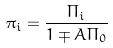<formula> <loc_0><loc_0><loc_500><loc_500>\pi _ { i } = \frac { \Pi _ { i } } { 1 \mp A \Pi _ { 0 } }</formula> 